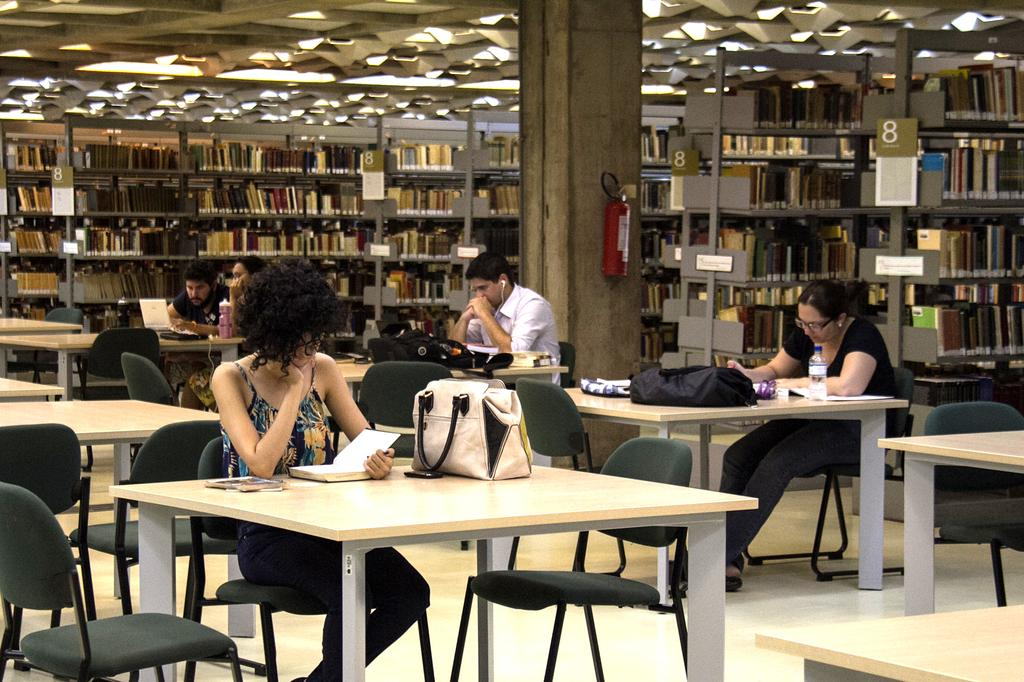What type of place is shown in the image? The image depicts a library. What are the people in the image doing? The people are sitting on chairs in the library. What activity are the people engaged in? The people are reading books. What type of lead can be seen in the image? There is no lead present in the image. Can you describe the maid in the image? There is no maid present in the image. 